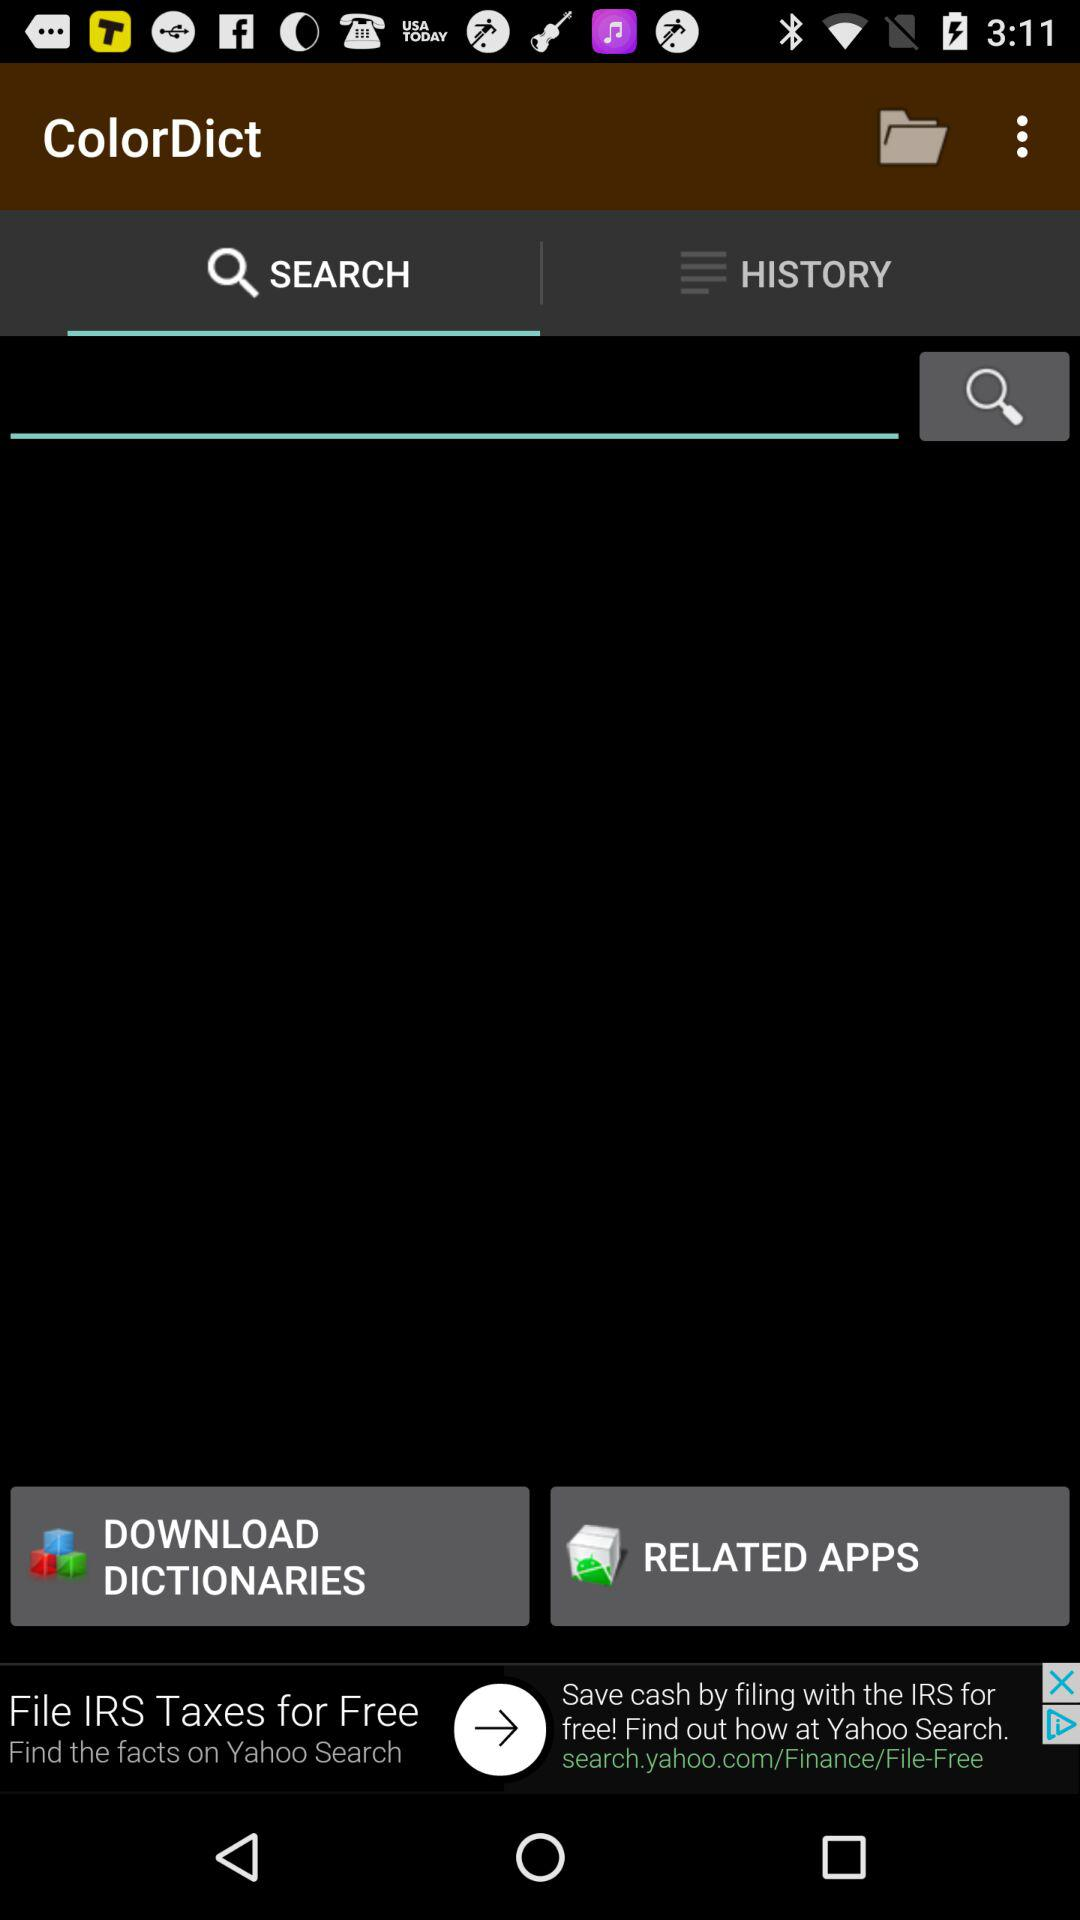Which tab is selected? The selected tab is "SEARCH". 